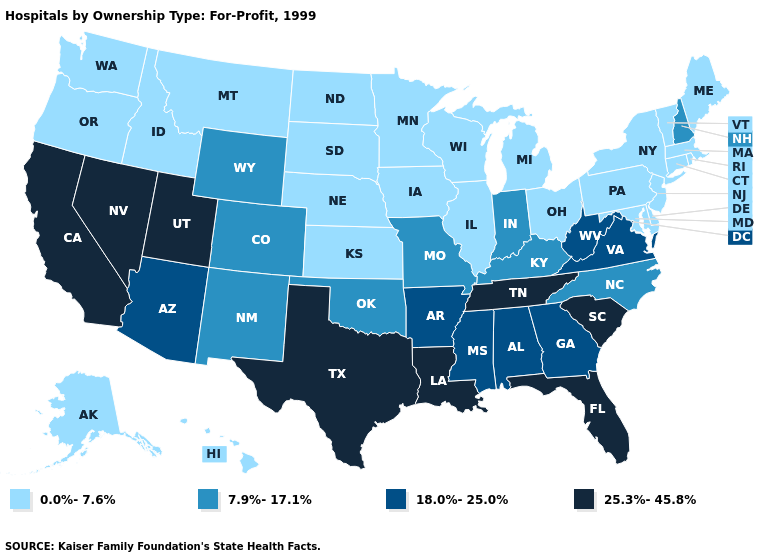Which states have the lowest value in the West?
Quick response, please. Alaska, Hawaii, Idaho, Montana, Oregon, Washington. Name the states that have a value in the range 25.3%-45.8%?
Quick response, please. California, Florida, Louisiana, Nevada, South Carolina, Tennessee, Texas, Utah. What is the highest value in states that border Mississippi?
Write a very short answer. 25.3%-45.8%. Among the states that border Nevada , does Utah have the lowest value?
Short answer required. No. What is the value of Maine?
Quick response, please. 0.0%-7.6%. Among the states that border Arkansas , does Tennessee have the highest value?
Quick response, please. Yes. What is the lowest value in states that border Washington?
Be succinct. 0.0%-7.6%. What is the value of South Carolina?
Give a very brief answer. 25.3%-45.8%. Name the states that have a value in the range 7.9%-17.1%?
Concise answer only. Colorado, Indiana, Kentucky, Missouri, New Hampshire, New Mexico, North Carolina, Oklahoma, Wyoming. Does the first symbol in the legend represent the smallest category?
Concise answer only. Yes. Name the states that have a value in the range 7.9%-17.1%?
Quick response, please. Colorado, Indiana, Kentucky, Missouri, New Hampshire, New Mexico, North Carolina, Oklahoma, Wyoming. What is the value of Maryland?
Concise answer only. 0.0%-7.6%. Does Tennessee have the lowest value in the South?
Be succinct. No. What is the lowest value in the Northeast?
Be succinct. 0.0%-7.6%. 